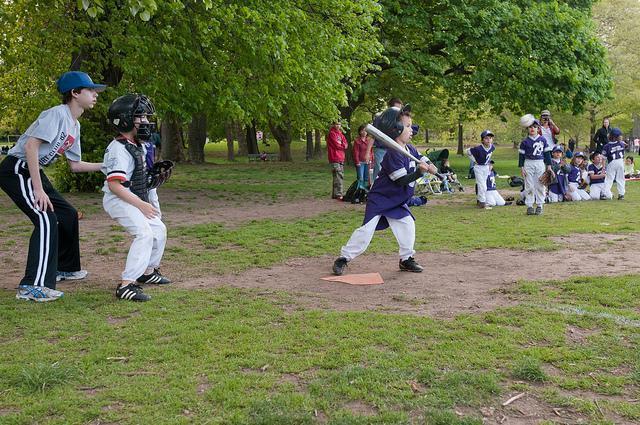How many people are there?
Give a very brief answer. 5. 